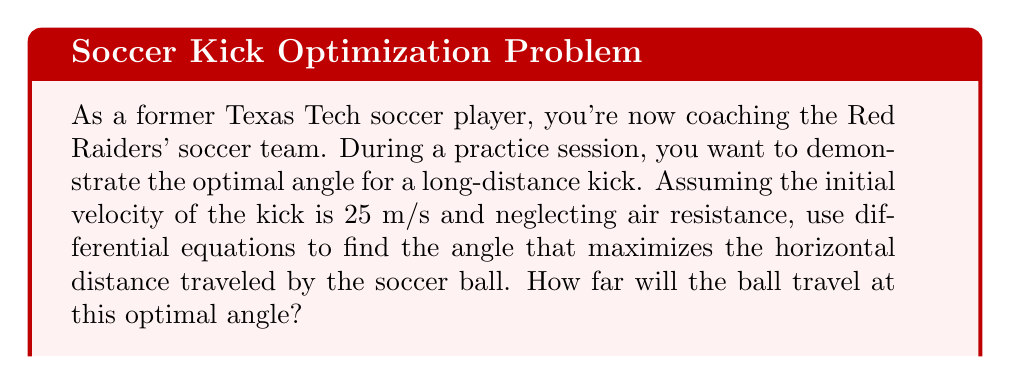Can you answer this question? Let's approach this problem step-by-step using differential equations:

1) First, we need to set up our equations of motion. In projectile motion, we have:

   $$\frac{d^2x}{dt^2} = 0$$
   $$\frac{d^2y}{dt^2} = -g$$

   Where $g$ is the acceleration due to gravity (9.8 m/s²).

2) Integrating these equations once, we get:

   $$\frac{dx}{dt} = v_0 \cos\theta$$
   $$\frac{dy}{dt} = v_0 \sin\theta - gt$$

   Where $v_0$ is the initial velocity (25 m/s) and $\theta$ is the launch angle.

3) Integrating again:

   $$x = (v_0 \cos\theta)t$$
   $$y = (v_0 \sin\theta)t - \frac{1}{2}gt^2$$

4) The ball lands when y = 0. Solving for t:

   $$0 = (v_0 \sin\theta)t - \frac{1}{2}gt^2$$
   $$t = \frac{2v_0 \sin\theta}{g}$$

5) Substituting this back into the equation for x:

   $$x = (v_0 \cos\theta)(\frac{2v_0 \sin\theta}{g})$$
   $$x = \frac{2v_0^2 \sin\theta \cos\theta}{g}$$

6) Using the trigonometric identity $\sin2\theta = 2\sin\theta\cos\theta$:

   $$x = \frac{v_0^2 \sin2\theta}{g}$$

7) To find the maximum, we differentiate with respect to $\theta$ and set to zero:

   $$\frac{dx}{d\theta} = \frac{v_0^2 \cos2\theta}{g} = 0$$

8) This is true when $\cos2\theta = 0$, which occurs when $2\theta = 90°$ or $\theta = 45°$.

9) Therefore, the optimal angle for maximum distance is 45°.

10) To find the distance, we substitute $\theta = 45°$ and $v_0 = 25$ m/s into our equation for x:

    $$x = \frac{25^2 \sin(2 * 45°)}{9.8} = \frac{625 * 1}{9.8} \approx 63.78\text{ m}$$
Answer: The optimal angle for maximum distance is 45°, and at this angle, the soccer ball will travel approximately 63.78 meters. 